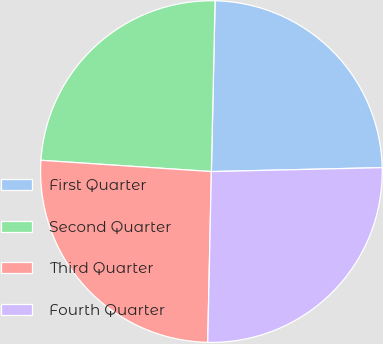Convert chart to OTSL. <chart><loc_0><loc_0><loc_500><loc_500><pie_chart><fcel>First Quarter<fcel>Second Quarter<fcel>Third Quarter<fcel>Fourth Quarter<nl><fcel>24.29%<fcel>24.29%<fcel>25.71%<fcel>25.71%<nl></chart> 